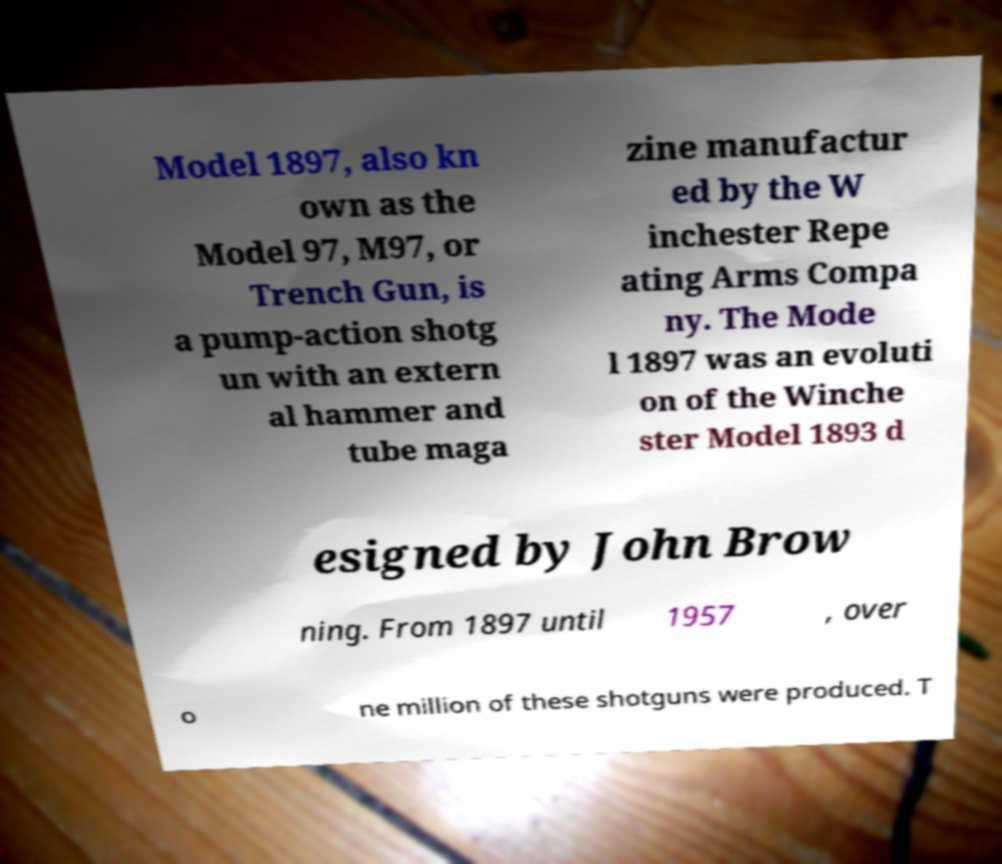Could you extract and type out the text from this image? Model 1897, also kn own as the Model 97, M97, or Trench Gun, is a pump-action shotg un with an extern al hammer and tube maga zine manufactur ed by the W inchester Repe ating Arms Compa ny. The Mode l 1897 was an evoluti on of the Winche ster Model 1893 d esigned by John Brow ning. From 1897 until 1957 , over o ne million of these shotguns were produced. T 